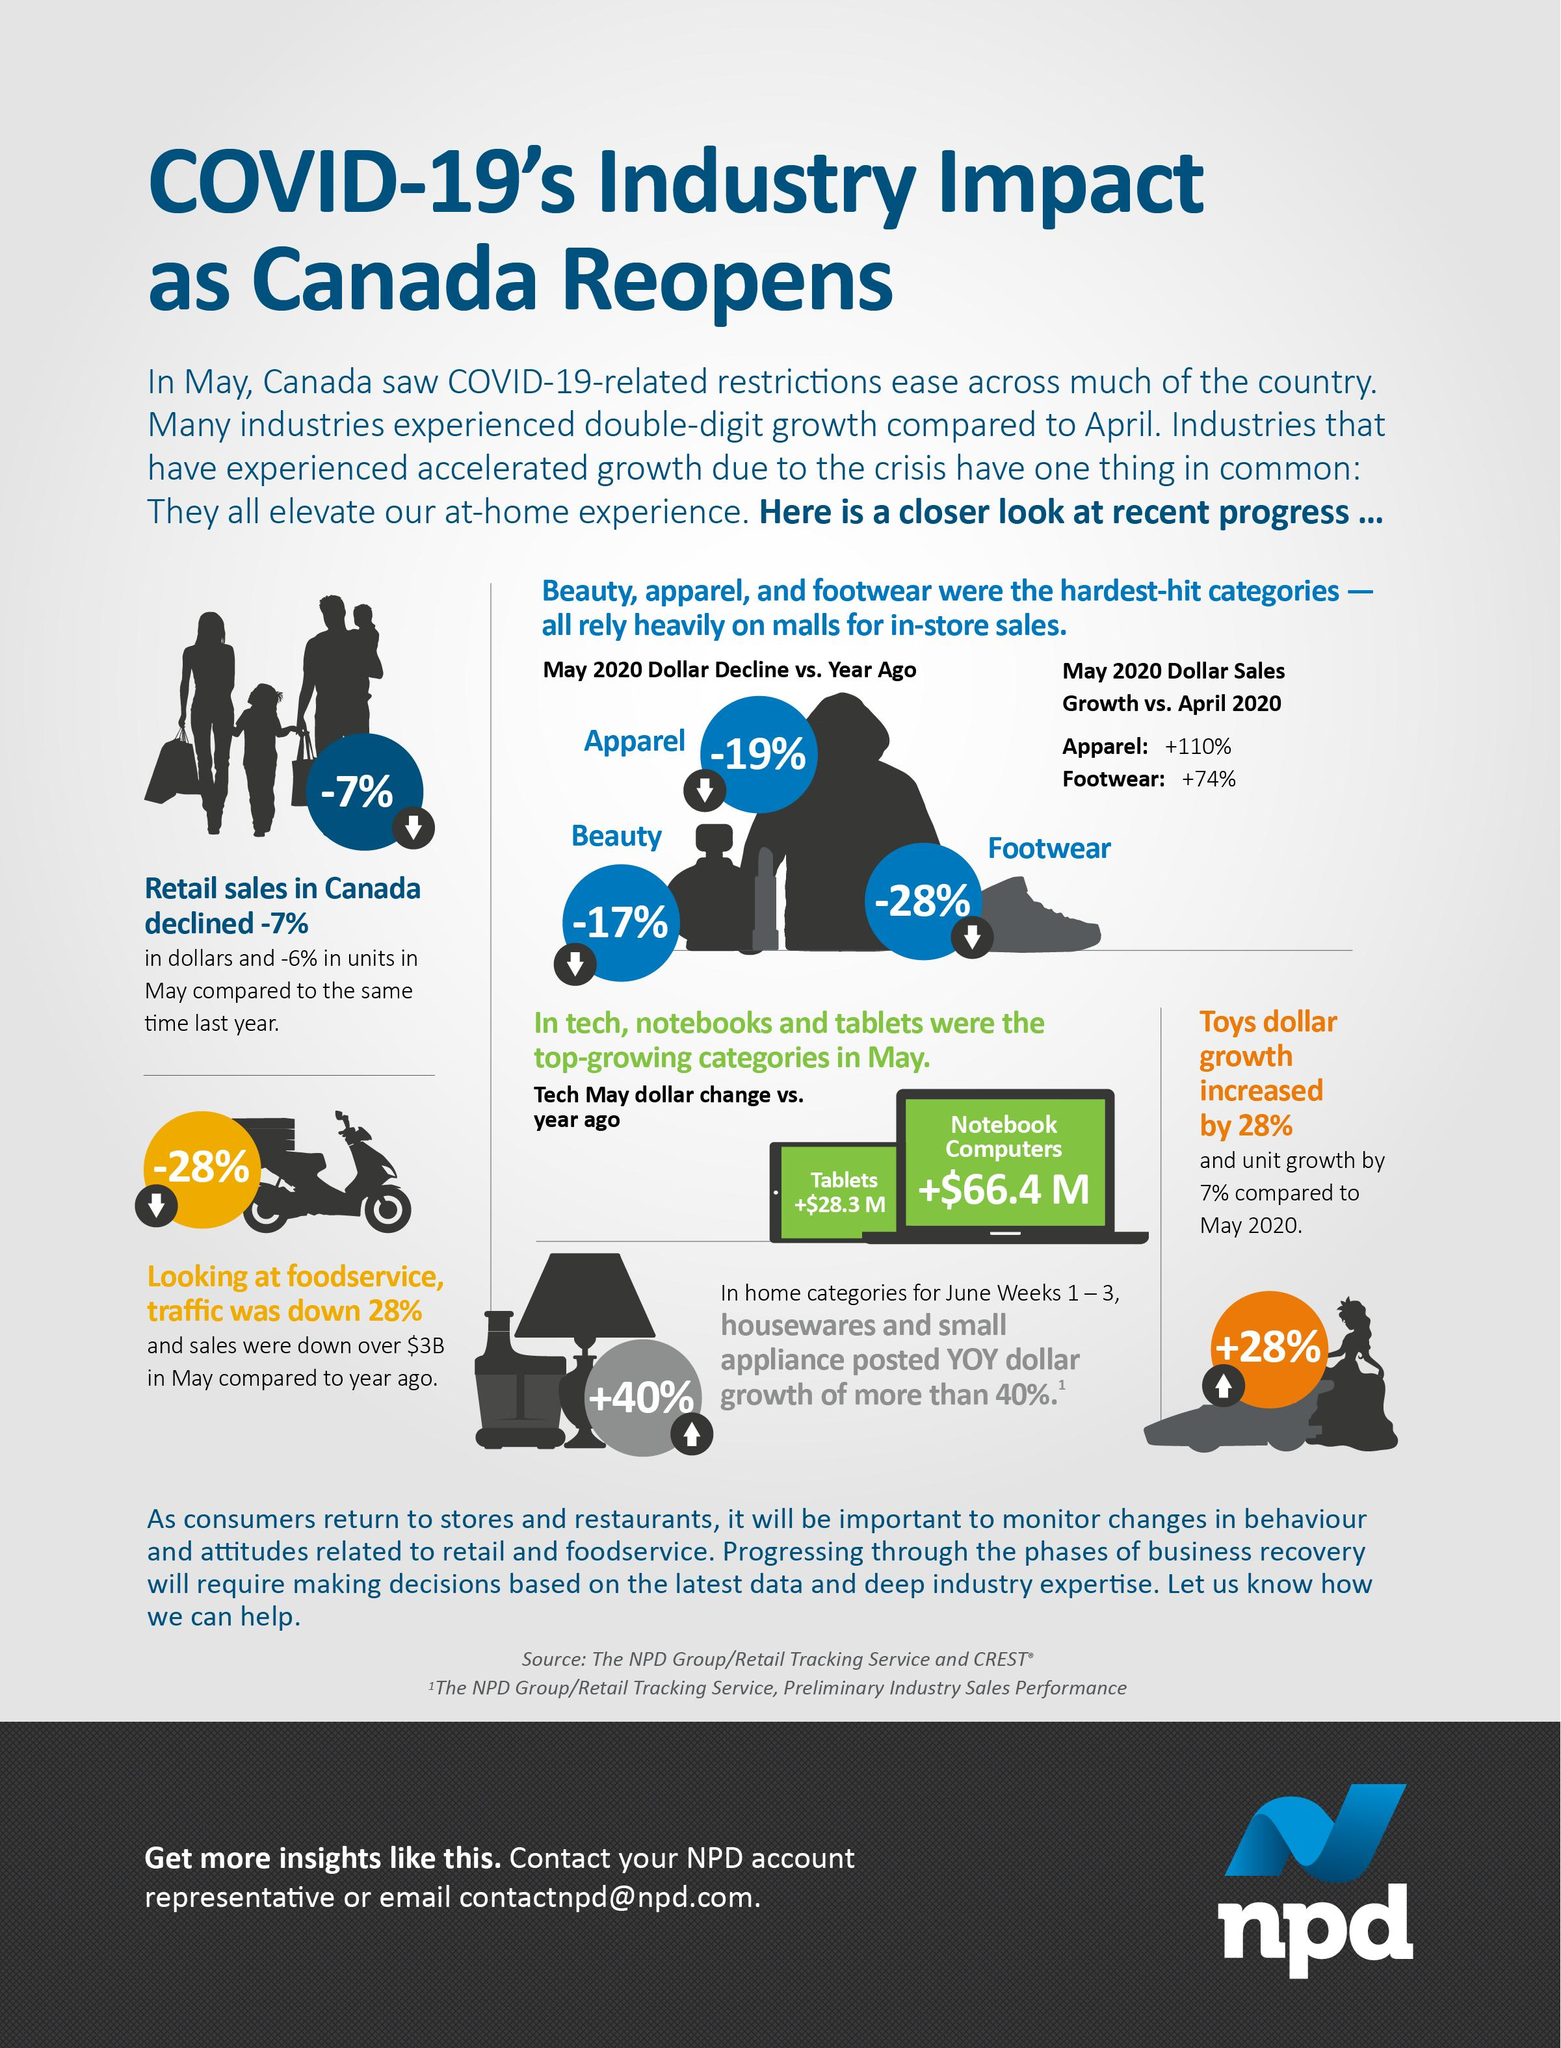Draw attention to some important aspects in this diagram. The COVID-19 pandemic has had a significant impact on the consumer goods industry, particularly in the areas of beauty, apparel, and footwear. These industries have been severely affected by the pandemic, resulting in significant losses for businesses and disruptions to the supply chain. As a result, many consumers have had to adjust their spending habits and seek alternative options for their beauty, apparel, and footwear needs. The tablets and notebook computers have demonstrated a significant growth in the technology industry. The item that has shown positive growth specifically among children is toys. 